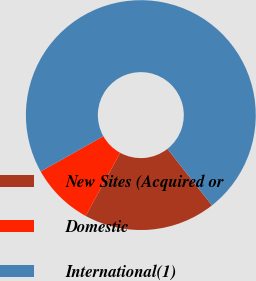Convert chart. <chart><loc_0><loc_0><loc_500><loc_500><pie_chart><fcel>New Sites (Acquired or<fcel>Domestic<fcel>International(1)<nl><fcel>18.59%<fcel>8.87%<fcel>72.54%<nl></chart> 